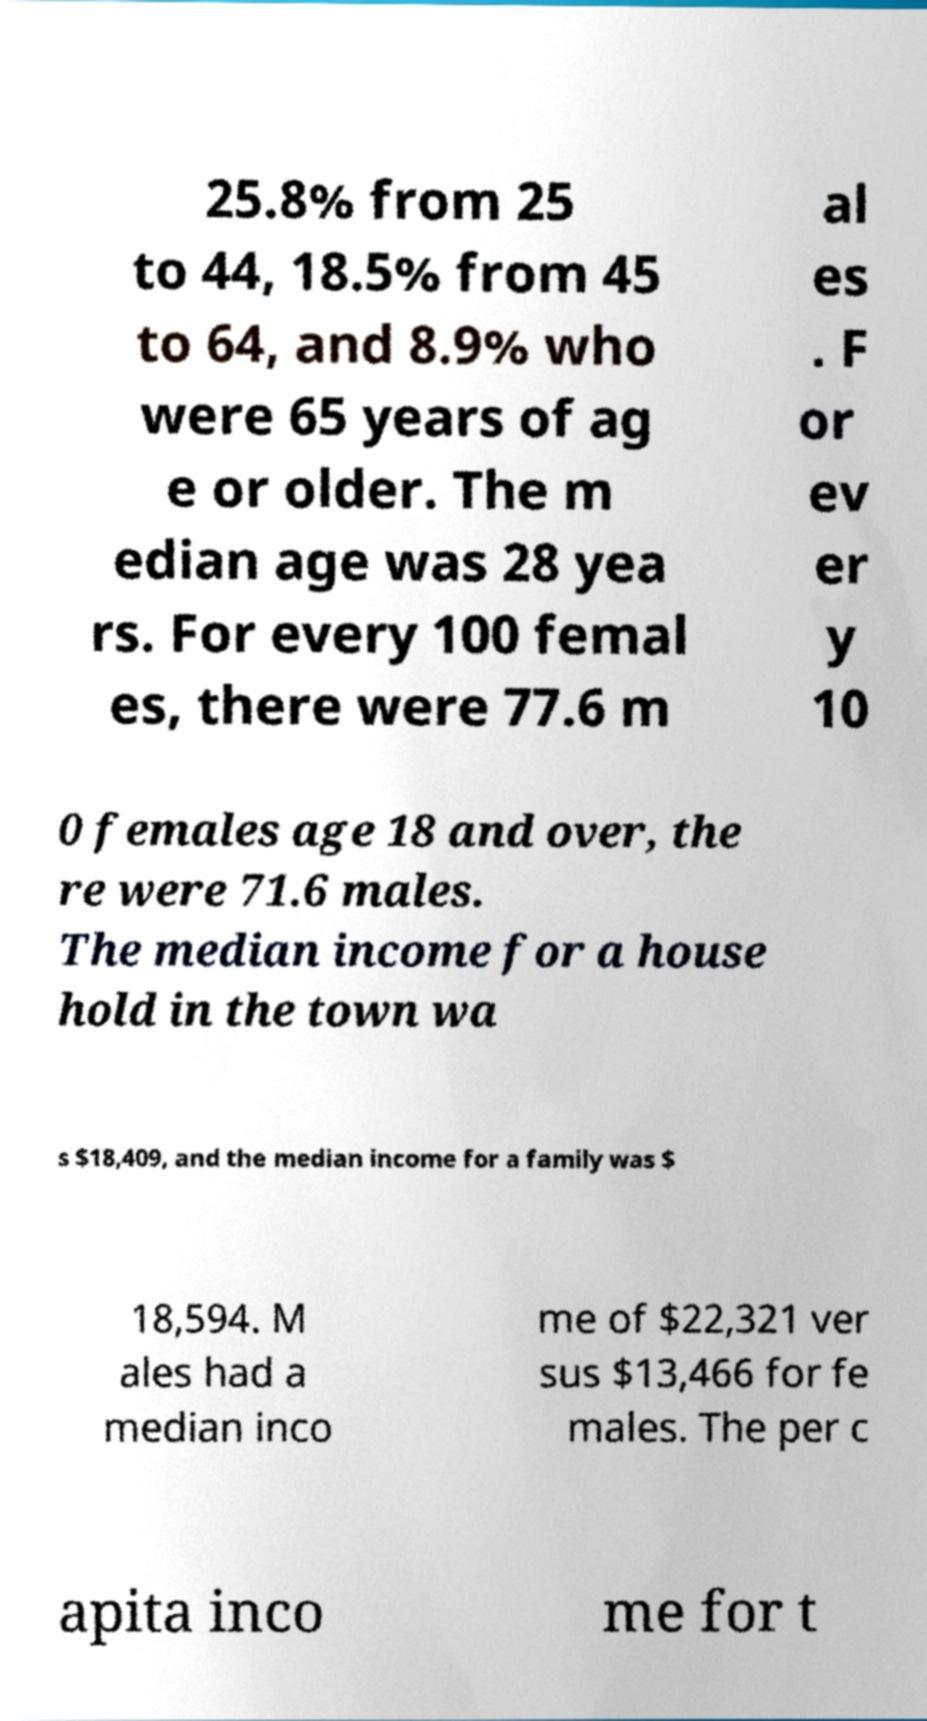Can you accurately transcribe the text from the provided image for me? 25.8% from 25 to 44, 18.5% from 45 to 64, and 8.9% who were 65 years of ag e or older. The m edian age was 28 yea rs. For every 100 femal es, there were 77.6 m al es . F or ev er y 10 0 females age 18 and over, the re were 71.6 males. The median income for a house hold in the town wa s $18,409, and the median income for a family was $ 18,594. M ales had a median inco me of $22,321 ver sus $13,466 for fe males. The per c apita inco me for t 